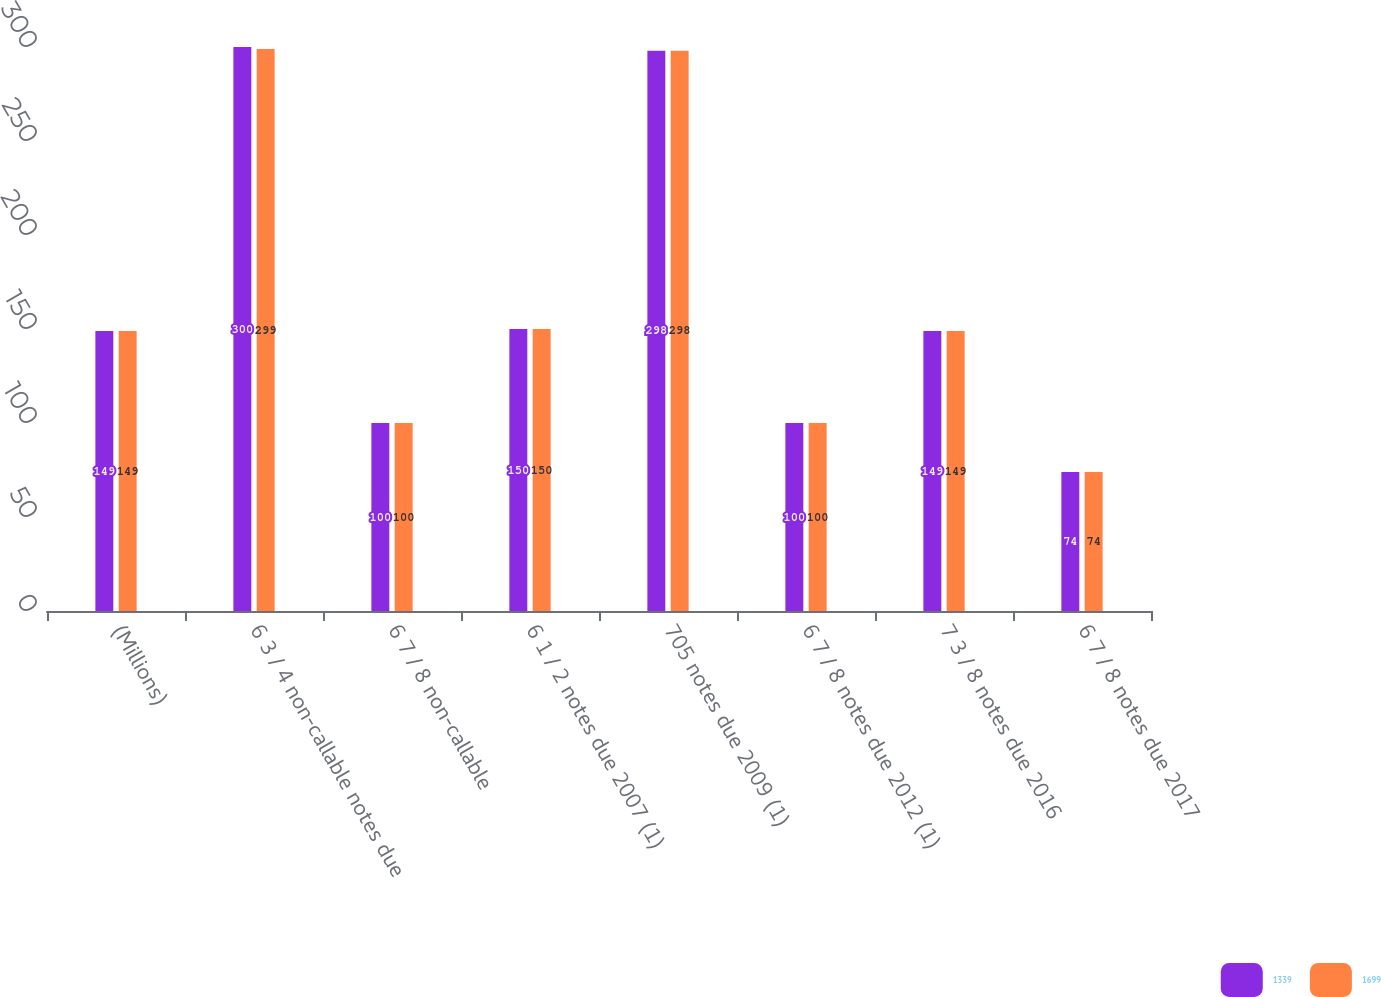<chart> <loc_0><loc_0><loc_500><loc_500><stacked_bar_chart><ecel><fcel>(Millions)<fcel>6 3 / 4 non-callable notes due<fcel>6 7 / 8 non-callable<fcel>6 1 / 2 notes due 2007 (1)<fcel>705 notes due 2009 (1)<fcel>6 7 / 8 notes due 2012 (1)<fcel>7 3 / 8 notes due 2016<fcel>6 7 / 8 notes due 2017<nl><fcel>1339<fcel>149<fcel>300<fcel>100<fcel>150<fcel>298<fcel>100<fcel>149<fcel>74<nl><fcel>1699<fcel>149<fcel>299<fcel>100<fcel>150<fcel>298<fcel>100<fcel>149<fcel>74<nl></chart> 